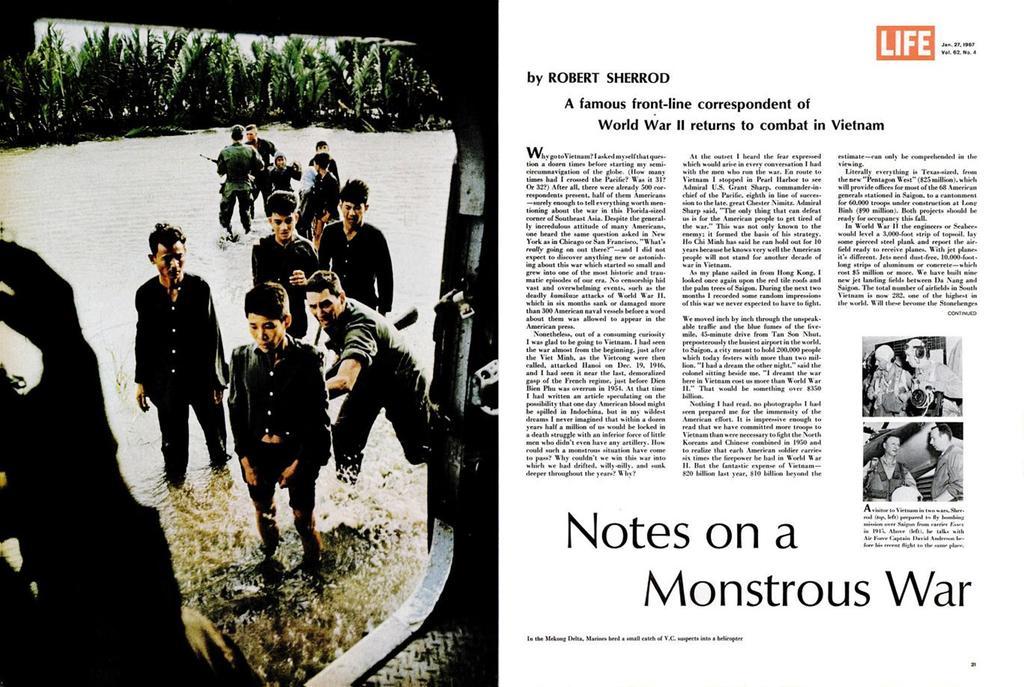Can you describe this image briefly? In the image there is an article and on the left side there are few pictures of some boys who are standing in the water, behind them there are many trees, it looks like the article is related to a world war. 